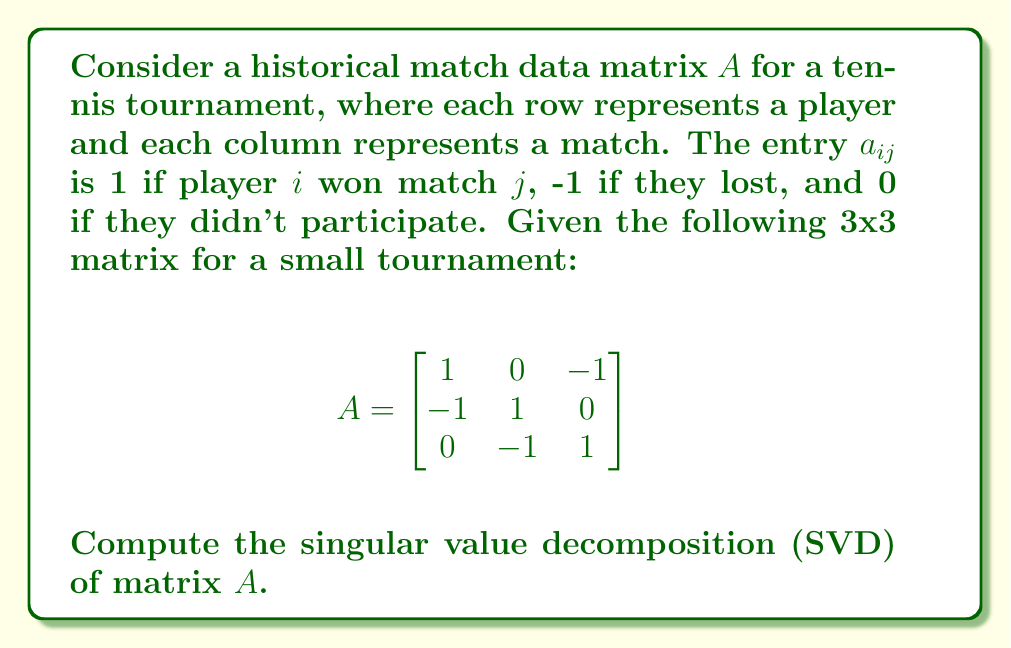What is the answer to this math problem? To compute the singular value decomposition of matrix $A$, we need to find matrices $U$, $\Sigma$, and $V^T$ such that $A = U\Sigma V^T$. Here's how we proceed:

1) First, calculate $A^TA$ and $AA^T$:

   $$A^TA = \begin{bmatrix}
   2 & -1 & -1 \\
   -1 & 2 & -1 \\
   -1 & -1 & 2
   \end{bmatrix}$$

   $$AA^T = \begin{bmatrix}
   2 & -1 & -1 \\
   -1 & 2 & -1 \\
   -1 & -1 & 2
   \end{bmatrix}$$

2) Find the eigenvalues of $A^TA$ (or $AA^T$, as they are the same):
   Characteristic equation: $\det(A^TA - \lambda I) = 0$
   $(\lambda - 3)(\lambda - 3)(\lambda - 0) = 0$
   Eigenvalues: $\lambda_1 = 3, \lambda_2 = 3, \lambda_3 = 0$

3) The singular values are the square roots of these eigenvalues:
   $\sigma_1 = \sqrt{3}, \sigma_2 = \sqrt{3}, \sigma_3 = 0$

4) Construct $\Sigma$:
   $$\Sigma = \begin{bmatrix}
   \sqrt{3} & 0 & 0 \\
   0 & \sqrt{3} & 0 \\
   0 & 0 & 0
   \end{bmatrix}$$

5) Find eigenvectors of $A^TA$ to get $V$:
   For $\lambda = 3$: $v_1 = \frac{1}{\sqrt{3}}[1, -1, -1]^T$, $v_2 = \frac{1}{\sqrt{2}}[1, 1, 0]^T$
   For $\lambda = 0$: $v_3 = \frac{1}{\sqrt{6}}[1, 1, -2]^T$

6) Find eigenvectors of $AA^T$ to get $U$:
   These are the same as $V$ in this case.

7) Construct $U$ and $V$:
   $$U = V = \begin{bmatrix}
   \frac{1}{\sqrt{3}} & \frac{1}{\sqrt{2}} & \frac{1}{\sqrt{6}} \\
   -\frac{1}{\sqrt{3}} & \frac{1}{\sqrt{2}} & \frac{1}{\sqrt{6}} \\
   -\frac{1}{\sqrt{3}} & 0 & -\frac{2}{\sqrt{6}}
   \end{bmatrix}$$

Therefore, the singular value decomposition of $A$ is $A = U\Sigma V^T$.
Answer: $A = U\Sigma V^T$, where $U = V = \begin{bmatrix}
\frac{1}{\sqrt{3}} & \frac{1}{\sqrt{2}} & \frac{1}{\sqrt{6}} \\
-\frac{1}{\sqrt{3}} & \frac{1}{\sqrt{2}} & \frac{1}{\sqrt{6}} \\
-\frac{1}{\sqrt{3}} & 0 & -\frac{2}{\sqrt{6}}
\end{bmatrix}$ and $\Sigma = \begin{bmatrix}
\sqrt{3} & 0 & 0 \\
0 & \sqrt{3} & 0 \\
0 & 0 & 0
\end{bmatrix}$ 